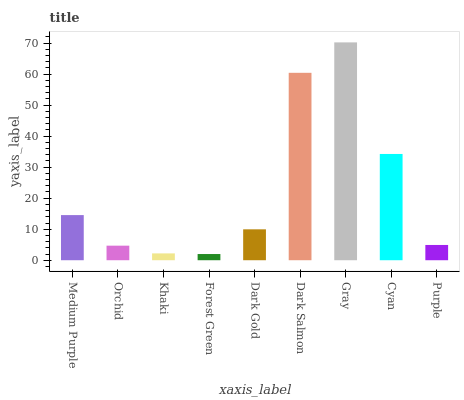Is Forest Green the minimum?
Answer yes or no. Yes. Is Gray the maximum?
Answer yes or no. Yes. Is Orchid the minimum?
Answer yes or no. No. Is Orchid the maximum?
Answer yes or no. No. Is Medium Purple greater than Orchid?
Answer yes or no. Yes. Is Orchid less than Medium Purple?
Answer yes or no. Yes. Is Orchid greater than Medium Purple?
Answer yes or no. No. Is Medium Purple less than Orchid?
Answer yes or no. No. Is Dark Gold the high median?
Answer yes or no. Yes. Is Dark Gold the low median?
Answer yes or no. Yes. Is Orchid the high median?
Answer yes or no. No. Is Gray the low median?
Answer yes or no. No. 